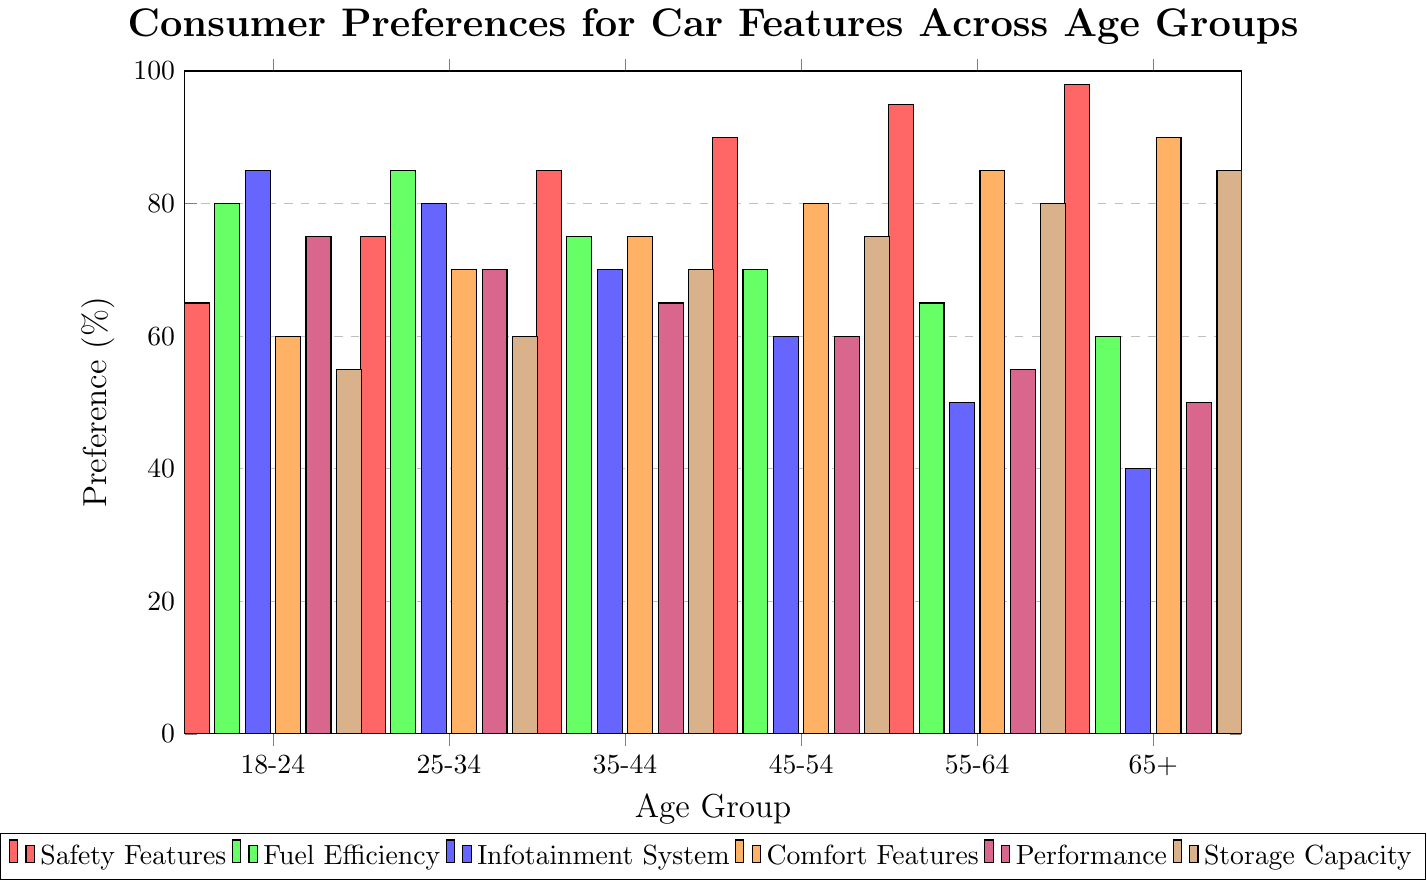Which age group prefers Safety Features the most? Look for the tallest bar in the red section across all age groups. The tallest red bar is at the 65+ age group with a preference percentage of 98%.
Answer: 65+ How does the preference for Fuel Efficiency change from ages 18-24 to 65+? Compare the green bars from age group 18-24 (80%) to age group 65+ (60%). The preference for Fuel Efficiency decreases from 80% to 60%.
Answer: Decreases Which feature has the highest preference among the 25-34 age group, and what is its percentage? Look at the bars for the 25-34 age group. The tallest bar for this age group is green, corresponding to Fuel Efficiency with an 85% preference.
Answer: Fuel Efficiency, 85% What is the average preference for Comfort Features across all age groups? Sum the preference percentages for Comfort Features (60, 70, 75, 80, 85, 90) and divide by the number of age groups (6). (60+70+75+80+85+90)/6 = 76.67%
Answer: 76.67% Which age group has the lowest preference for Infotainment System? Look for the shortest blue bar across all age groups. The shortest blue bar is in the 65+ age group with a preference percentage of 40%.
Answer: 65+ Compare the preferences for Performance and Storage Capacity in the 45-54 age group. Which one is higher? Look at the purple and brown bars for the 45-54 age group. The Storage Capacity preference (75%) is higher than Performance (60%).
Answer: Storage Capacity In which age group does Comfort Features have a higher preference than Fuel Efficiency? Compare the orange and green bars for each age group. In the 55-64 and 65+ age groups, Comfort Features (85% and 90%) are preferred more than Fuel Efficiency (65% and 60%).
Answer: 55-64, 65+ What's the total preference percentage for Safety Features across all age groups? Sum the preference percentages for Safety Features (65, 75, 85, 90, 95, 98). 65+75+85+90+95+98 = 508%
Answer: 508% What is the difference in the preference for Storage Capacity between the 18-24 and 65+ age groups? Subtract the preference percentage of Storage Capacity for the 18-24 age group (55%) from the 65+ age group (85%). 85 - 55 = 30%
Answer: 30% Which features have a consistently increasing preference with age? Examine each feature's bar pattern across age groups. Safety Features consistently increase from 65% to 98%, and Storage Capacity has a general increasing trend from 55% to 85%.
Answer: Safety Features, Storage Capacity 